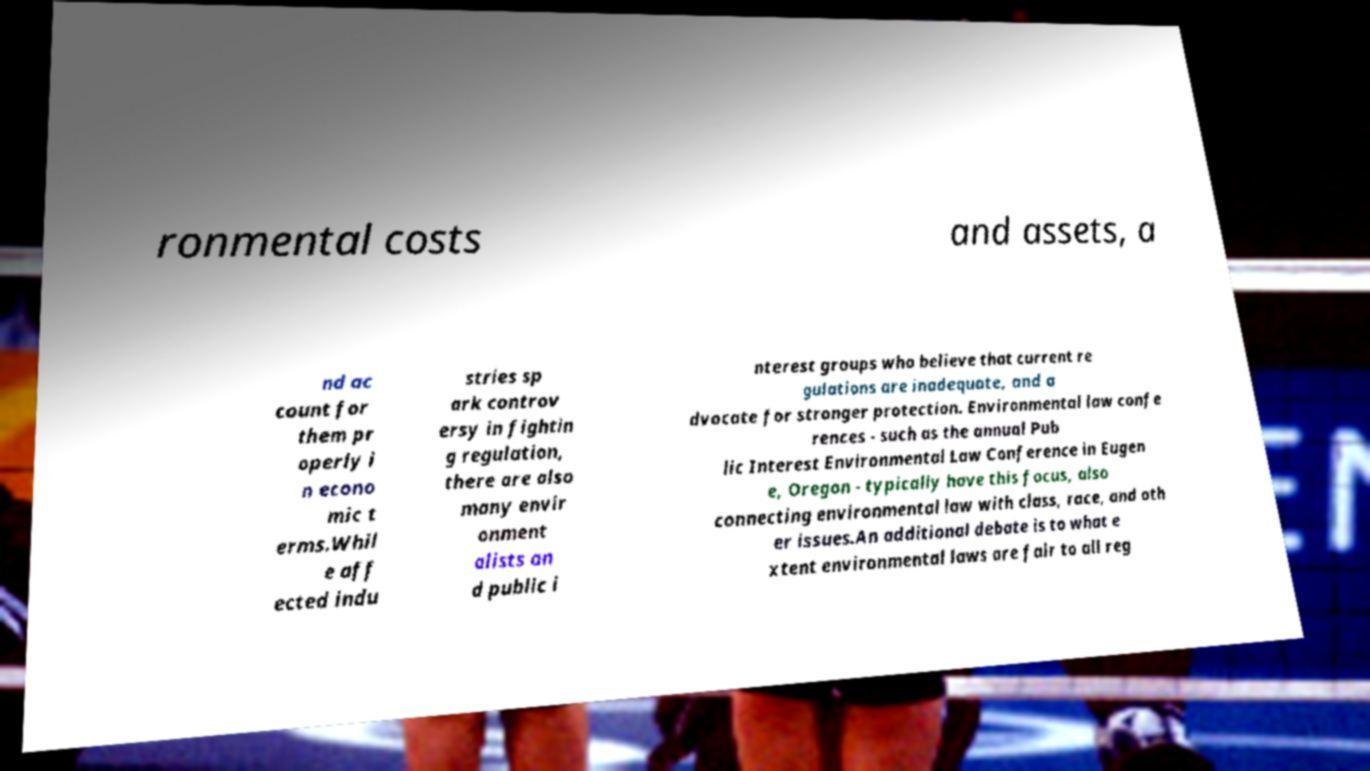Could you extract and type out the text from this image? ronmental costs and assets, a nd ac count for them pr operly i n econo mic t erms.Whil e aff ected indu stries sp ark controv ersy in fightin g regulation, there are also many envir onment alists an d public i nterest groups who believe that current re gulations are inadequate, and a dvocate for stronger protection. Environmental law confe rences - such as the annual Pub lic Interest Environmental Law Conference in Eugen e, Oregon - typically have this focus, also connecting environmental law with class, race, and oth er issues.An additional debate is to what e xtent environmental laws are fair to all reg 